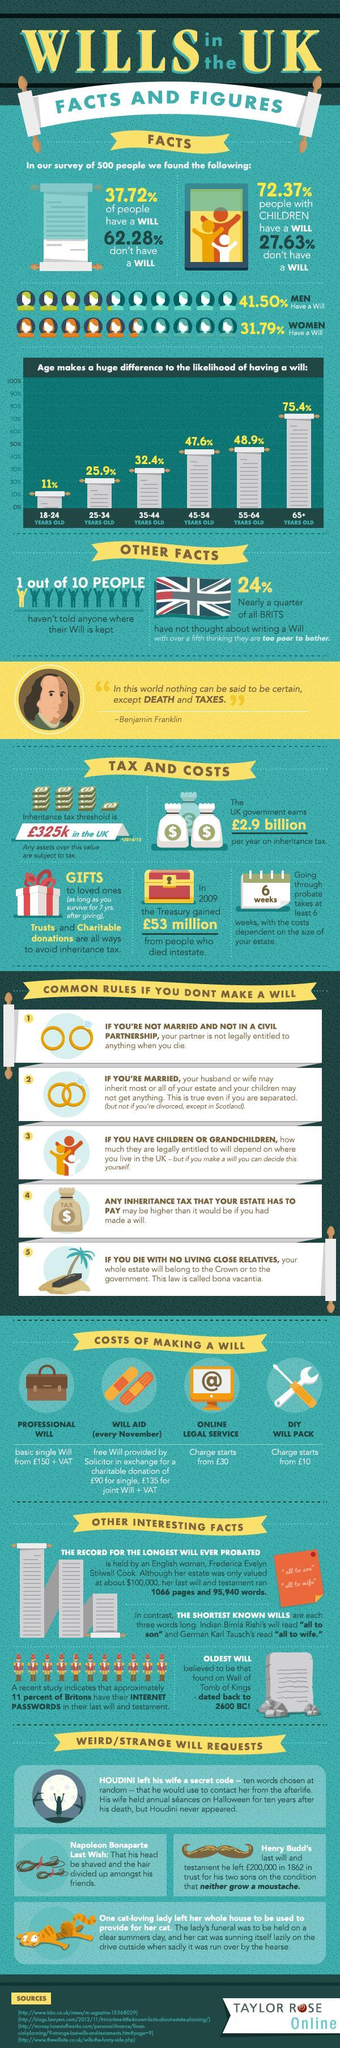What is percentage difference of men and women writing a will ?
Answer the question with a short phrase. 9.71% What were the three words written in world's shortest wills? " all to son", "all to wife" 